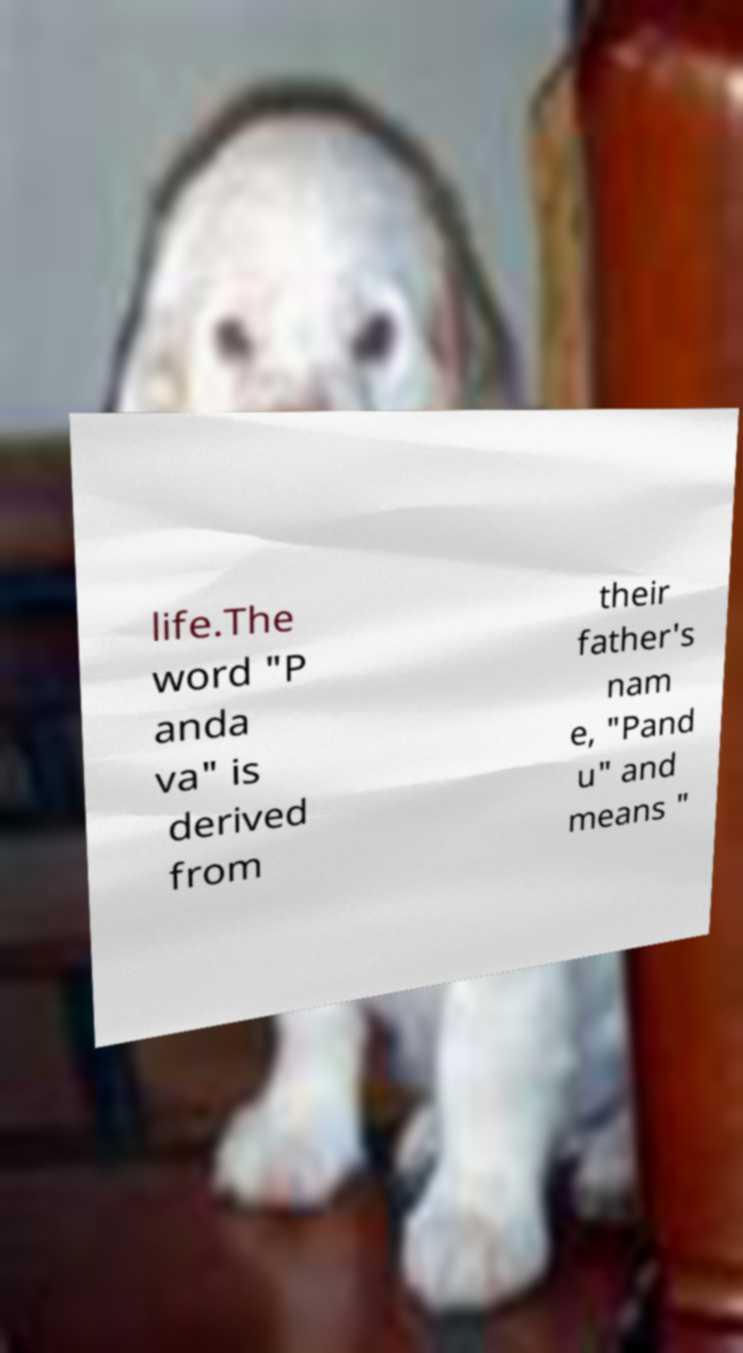For documentation purposes, I need the text within this image transcribed. Could you provide that? life.The word "P anda va" is derived from their father's nam e, "Pand u" and means " 